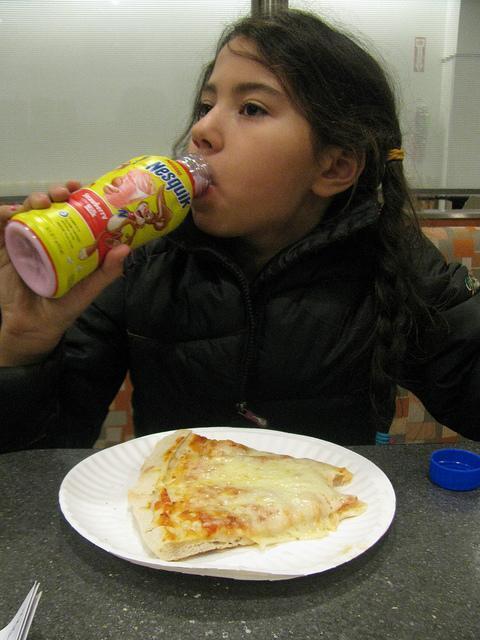How many orange cones are there?
Give a very brief answer. 0. 